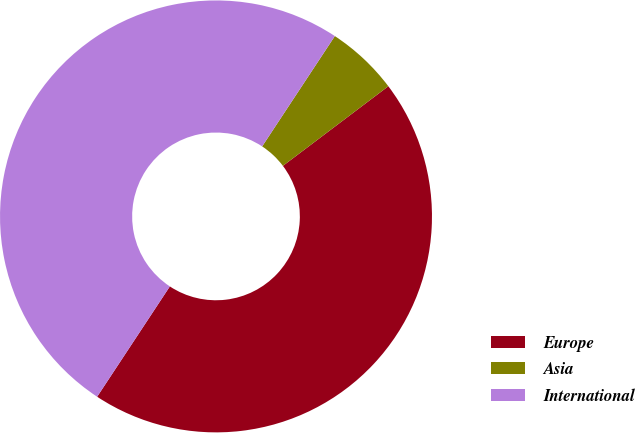Convert chart to OTSL. <chart><loc_0><loc_0><loc_500><loc_500><pie_chart><fcel>Europe<fcel>Asia<fcel>International<nl><fcel>44.57%<fcel>5.43%<fcel>50.0%<nl></chart> 